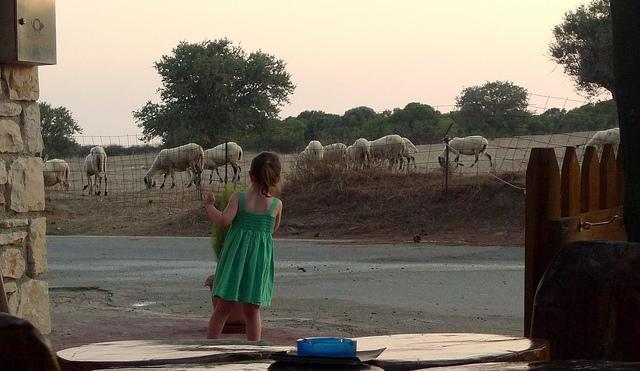How many chairs are in the picture?
Give a very brief answer. 2. How many airplanes are visible to the left side of the front plane?
Give a very brief answer. 0. 